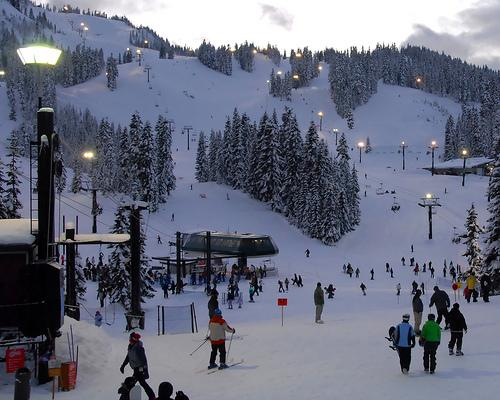What does this scene look most like? Please explain your reasoning. winter wonderland. This place has winter weather and is a tourist destination. 